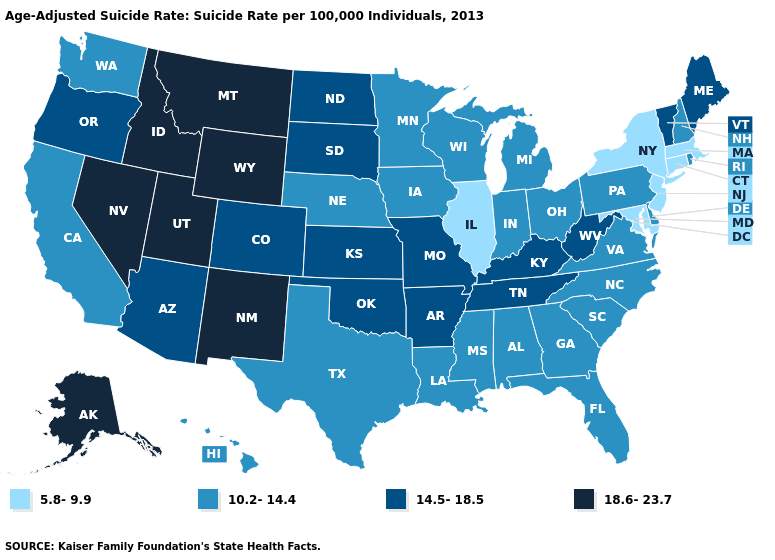Is the legend a continuous bar?
Give a very brief answer. No. What is the highest value in the MidWest ?
Answer briefly. 14.5-18.5. Name the states that have a value in the range 18.6-23.7?
Answer briefly. Alaska, Idaho, Montana, Nevada, New Mexico, Utah, Wyoming. Name the states that have a value in the range 14.5-18.5?
Write a very short answer. Arizona, Arkansas, Colorado, Kansas, Kentucky, Maine, Missouri, North Dakota, Oklahoma, Oregon, South Dakota, Tennessee, Vermont, West Virginia. Which states have the lowest value in the USA?
Answer briefly. Connecticut, Illinois, Maryland, Massachusetts, New Jersey, New York. Name the states that have a value in the range 18.6-23.7?
Concise answer only. Alaska, Idaho, Montana, Nevada, New Mexico, Utah, Wyoming. What is the value of Utah?
Short answer required. 18.6-23.7. Which states have the lowest value in the USA?
Quick response, please. Connecticut, Illinois, Maryland, Massachusetts, New Jersey, New York. Which states have the lowest value in the West?
Answer briefly. California, Hawaii, Washington. Which states have the lowest value in the USA?
Write a very short answer. Connecticut, Illinois, Maryland, Massachusetts, New Jersey, New York. Which states have the lowest value in the USA?
Answer briefly. Connecticut, Illinois, Maryland, Massachusetts, New Jersey, New York. Does Hawaii have the same value as Arkansas?
Keep it brief. No. Name the states that have a value in the range 18.6-23.7?
Be succinct. Alaska, Idaho, Montana, Nevada, New Mexico, Utah, Wyoming. What is the value of Virginia?
Answer briefly. 10.2-14.4. What is the value of Washington?
Keep it brief. 10.2-14.4. 